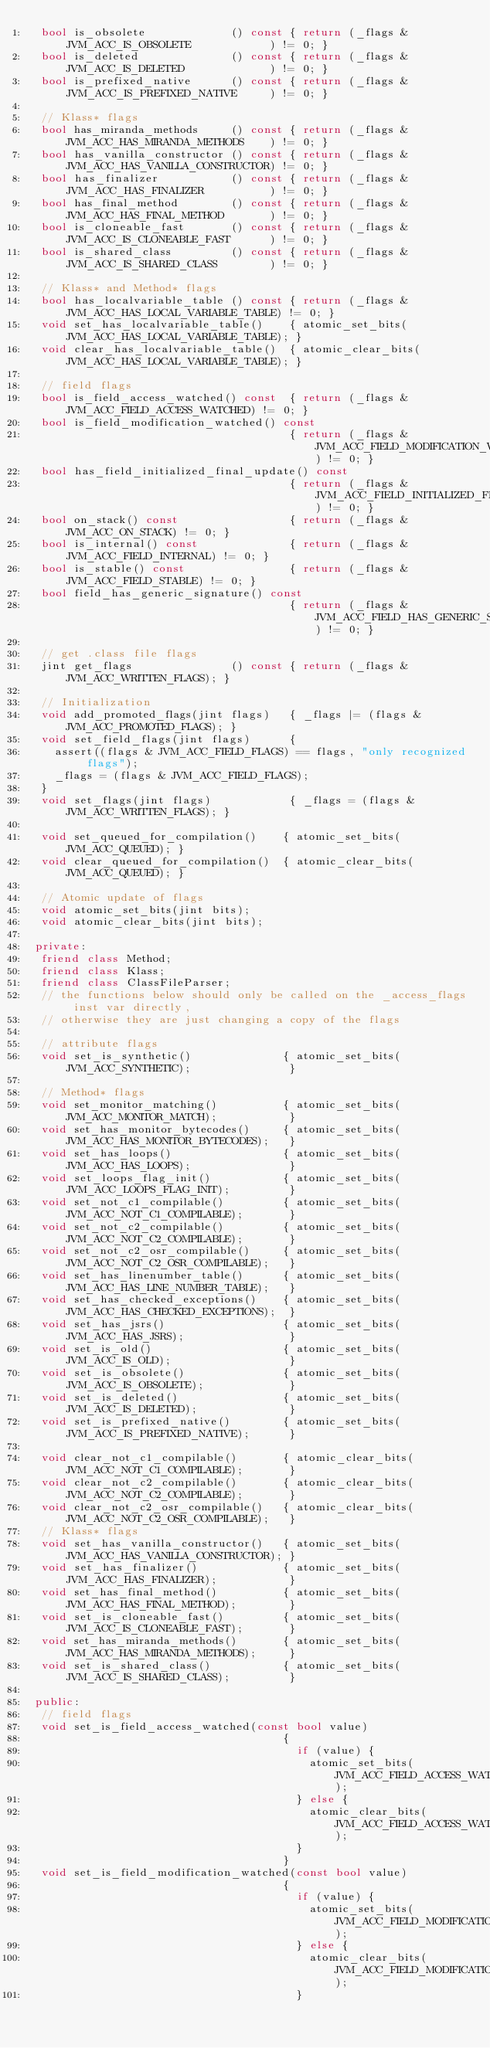Convert code to text. <code><loc_0><loc_0><loc_500><loc_500><_C++_>  bool is_obsolete             () const { return (_flags & JVM_ACC_IS_OBSOLETE            ) != 0; }
  bool is_deleted              () const { return (_flags & JVM_ACC_IS_DELETED             ) != 0; }
  bool is_prefixed_native      () const { return (_flags & JVM_ACC_IS_PREFIXED_NATIVE     ) != 0; }

  // Klass* flags
  bool has_miranda_methods     () const { return (_flags & JVM_ACC_HAS_MIRANDA_METHODS    ) != 0; }
  bool has_vanilla_constructor () const { return (_flags & JVM_ACC_HAS_VANILLA_CONSTRUCTOR) != 0; }
  bool has_finalizer           () const { return (_flags & JVM_ACC_HAS_FINALIZER          ) != 0; }
  bool has_final_method        () const { return (_flags & JVM_ACC_HAS_FINAL_METHOD       ) != 0; }
  bool is_cloneable_fast       () const { return (_flags & JVM_ACC_IS_CLONEABLE_FAST      ) != 0; }
  bool is_shared_class         () const { return (_flags & JVM_ACC_IS_SHARED_CLASS        ) != 0; }

  // Klass* and Method* flags
  bool has_localvariable_table () const { return (_flags & JVM_ACC_HAS_LOCAL_VARIABLE_TABLE) != 0; }
  void set_has_localvariable_table()    { atomic_set_bits(JVM_ACC_HAS_LOCAL_VARIABLE_TABLE); }
  void clear_has_localvariable_table()  { atomic_clear_bits(JVM_ACC_HAS_LOCAL_VARIABLE_TABLE); }

  // field flags
  bool is_field_access_watched() const  { return (_flags & JVM_ACC_FIELD_ACCESS_WATCHED) != 0; }
  bool is_field_modification_watched() const
                                        { return (_flags & JVM_ACC_FIELD_MODIFICATION_WATCHED) != 0; }
  bool has_field_initialized_final_update() const
                                        { return (_flags & JVM_ACC_FIELD_INITIALIZED_FINAL_UPDATE) != 0; }
  bool on_stack() const                 { return (_flags & JVM_ACC_ON_STACK) != 0; }
  bool is_internal() const              { return (_flags & JVM_ACC_FIELD_INTERNAL) != 0; }
  bool is_stable() const                { return (_flags & JVM_ACC_FIELD_STABLE) != 0; }
  bool field_has_generic_signature() const
                                        { return (_flags & JVM_ACC_FIELD_HAS_GENERIC_SIGNATURE) != 0; }

  // get .class file flags
  jint get_flags               () const { return (_flags & JVM_ACC_WRITTEN_FLAGS); }

  // Initialization
  void add_promoted_flags(jint flags)   { _flags |= (flags & JVM_ACC_PROMOTED_FLAGS); }
  void set_field_flags(jint flags)      {
    assert((flags & JVM_ACC_FIELD_FLAGS) == flags, "only recognized flags");
    _flags = (flags & JVM_ACC_FIELD_FLAGS);
  }
  void set_flags(jint flags)            { _flags = (flags & JVM_ACC_WRITTEN_FLAGS); }

  void set_queued_for_compilation()    { atomic_set_bits(JVM_ACC_QUEUED); }
  void clear_queued_for_compilation()  { atomic_clear_bits(JVM_ACC_QUEUED); }

  // Atomic update of flags
  void atomic_set_bits(jint bits);
  void atomic_clear_bits(jint bits);

 private:
  friend class Method;
  friend class Klass;
  friend class ClassFileParser;
  // the functions below should only be called on the _access_flags inst var directly,
  // otherwise they are just changing a copy of the flags

  // attribute flags
  void set_is_synthetic()              { atomic_set_bits(JVM_ACC_SYNTHETIC);               }

  // Method* flags
  void set_monitor_matching()          { atomic_set_bits(JVM_ACC_MONITOR_MATCH);           }
  void set_has_monitor_bytecodes()     { atomic_set_bits(JVM_ACC_HAS_MONITOR_BYTECODES);   }
  void set_has_loops()                 { atomic_set_bits(JVM_ACC_HAS_LOOPS);               }
  void set_loops_flag_init()           { atomic_set_bits(JVM_ACC_LOOPS_FLAG_INIT);         }
  void set_not_c1_compilable()         { atomic_set_bits(JVM_ACC_NOT_C1_COMPILABLE);       }
  void set_not_c2_compilable()         { atomic_set_bits(JVM_ACC_NOT_C2_COMPILABLE);       }
  void set_not_c2_osr_compilable()     { atomic_set_bits(JVM_ACC_NOT_C2_OSR_COMPILABLE);   }
  void set_has_linenumber_table()      { atomic_set_bits(JVM_ACC_HAS_LINE_NUMBER_TABLE);   }
  void set_has_checked_exceptions()    { atomic_set_bits(JVM_ACC_HAS_CHECKED_EXCEPTIONS);  }
  void set_has_jsrs()                  { atomic_set_bits(JVM_ACC_HAS_JSRS);                }
  void set_is_old()                    { atomic_set_bits(JVM_ACC_IS_OLD);                  }
  void set_is_obsolete()               { atomic_set_bits(JVM_ACC_IS_OBSOLETE);             }
  void set_is_deleted()                { atomic_set_bits(JVM_ACC_IS_DELETED);              }
  void set_is_prefixed_native()        { atomic_set_bits(JVM_ACC_IS_PREFIXED_NATIVE);      }

  void clear_not_c1_compilable()       { atomic_clear_bits(JVM_ACC_NOT_C1_COMPILABLE);       }
  void clear_not_c2_compilable()       { atomic_clear_bits(JVM_ACC_NOT_C2_COMPILABLE);       }
  void clear_not_c2_osr_compilable()   { atomic_clear_bits(JVM_ACC_NOT_C2_OSR_COMPILABLE);   }
  // Klass* flags
  void set_has_vanilla_constructor()   { atomic_set_bits(JVM_ACC_HAS_VANILLA_CONSTRUCTOR); }
  void set_has_finalizer()             { atomic_set_bits(JVM_ACC_HAS_FINALIZER);           }
  void set_has_final_method()          { atomic_set_bits(JVM_ACC_HAS_FINAL_METHOD);        }
  void set_is_cloneable_fast()         { atomic_set_bits(JVM_ACC_IS_CLONEABLE_FAST);       }
  void set_has_miranda_methods()       { atomic_set_bits(JVM_ACC_HAS_MIRANDA_METHODS);     }
  void set_is_shared_class()           { atomic_set_bits(JVM_ACC_IS_SHARED_CLASS);         }

 public:
  // field flags
  void set_is_field_access_watched(const bool value)
                                       {
                                         if (value) {
                                           atomic_set_bits(JVM_ACC_FIELD_ACCESS_WATCHED);
                                         } else {
                                           atomic_clear_bits(JVM_ACC_FIELD_ACCESS_WATCHED);
                                         }
                                       }
  void set_is_field_modification_watched(const bool value)
                                       {
                                         if (value) {
                                           atomic_set_bits(JVM_ACC_FIELD_MODIFICATION_WATCHED);
                                         } else {
                                           atomic_clear_bits(JVM_ACC_FIELD_MODIFICATION_WATCHED);
                                         }</code> 